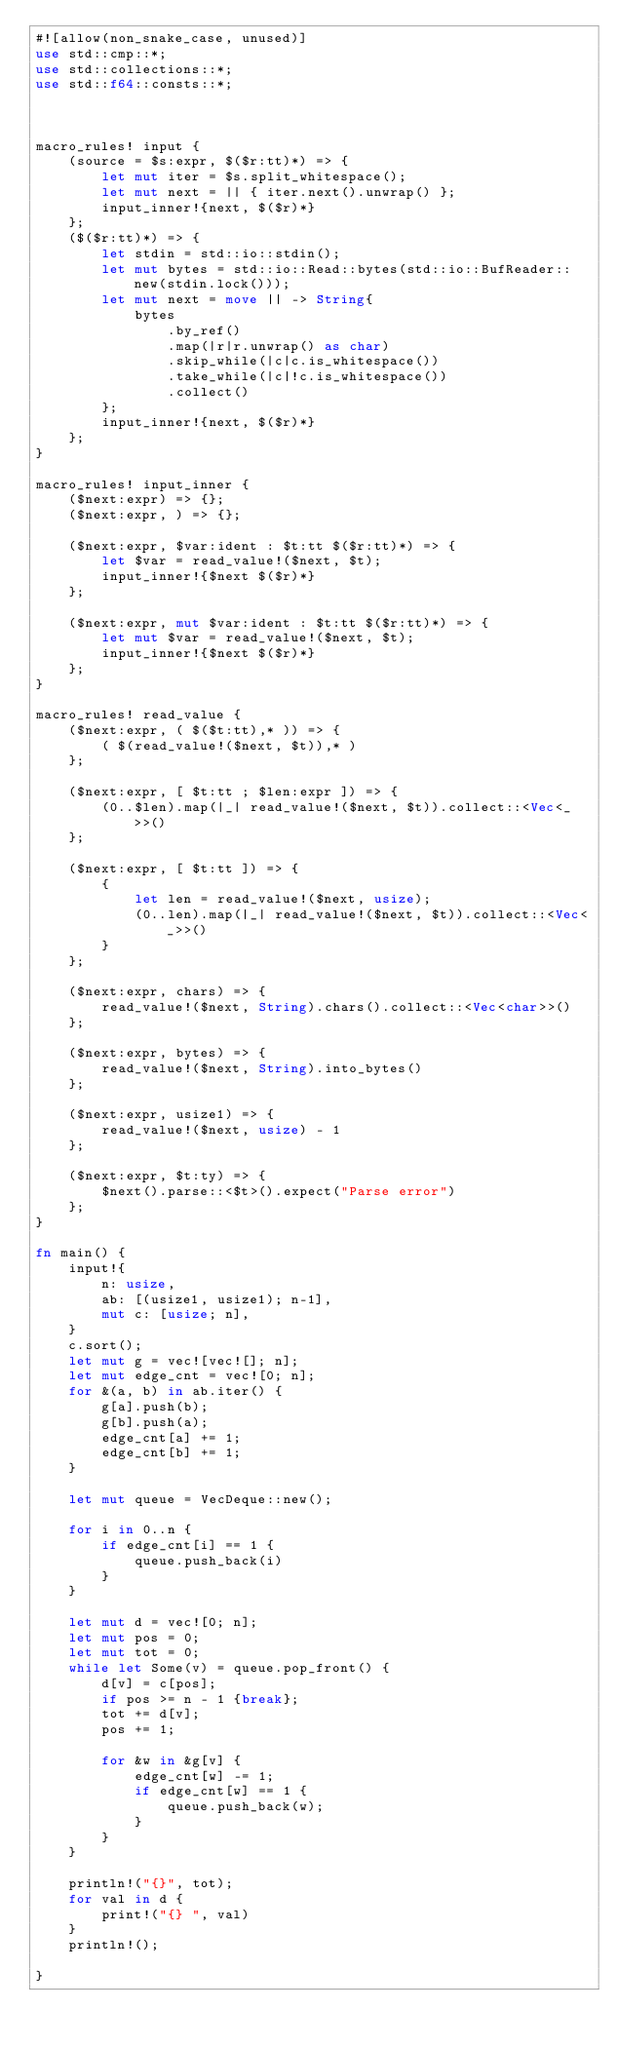<code> <loc_0><loc_0><loc_500><loc_500><_Rust_>#![allow(non_snake_case, unused)]
use std::cmp::*;
use std::collections::*;
use std::f64::consts::*;



macro_rules! input {
    (source = $s:expr, $($r:tt)*) => {
        let mut iter = $s.split_whitespace();
        let mut next = || { iter.next().unwrap() };
        input_inner!{next, $($r)*}
    };
    ($($r:tt)*) => {
        let stdin = std::io::stdin();
        let mut bytes = std::io::Read::bytes(std::io::BufReader::new(stdin.lock()));
        let mut next = move || -> String{
            bytes
                .by_ref()
                .map(|r|r.unwrap() as char)
                .skip_while(|c|c.is_whitespace())
                .take_while(|c|!c.is_whitespace())
                .collect()
        };
        input_inner!{next, $($r)*}
    };
}

macro_rules! input_inner {
    ($next:expr) => {};
    ($next:expr, ) => {};

    ($next:expr, $var:ident : $t:tt $($r:tt)*) => {
        let $var = read_value!($next, $t);
        input_inner!{$next $($r)*}
    };

    ($next:expr, mut $var:ident : $t:tt $($r:tt)*) => {
        let mut $var = read_value!($next, $t);
        input_inner!{$next $($r)*}
    };
}

macro_rules! read_value {
    ($next:expr, ( $($t:tt),* )) => {
        ( $(read_value!($next, $t)),* )
    };

    ($next:expr, [ $t:tt ; $len:expr ]) => {
        (0..$len).map(|_| read_value!($next, $t)).collect::<Vec<_>>()
    };

    ($next:expr, [ $t:tt ]) => {
        {
            let len = read_value!($next, usize);
            (0..len).map(|_| read_value!($next, $t)).collect::<Vec<_>>()
        }
    };

    ($next:expr, chars) => {
        read_value!($next, String).chars().collect::<Vec<char>>()
    };

    ($next:expr, bytes) => {
        read_value!($next, String).into_bytes()
    };

    ($next:expr, usize1) => {
        read_value!($next, usize) - 1
    };

    ($next:expr, $t:ty) => {
        $next().parse::<$t>().expect("Parse error")
    };
}

fn main() {
    input!{
        n: usize,
        ab: [(usize1, usize1); n-1],
        mut c: [usize; n],
    }
    c.sort();
    let mut g = vec![vec![]; n];
    let mut edge_cnt = vec![0; n];
    for &(a, b) in ab.iter() {
        g[a].push(b);
        g[b].push(a);
        edge_cnt[a] += 1;
        edge_cnt[b] += 1;
    }

    let mut queue = VecDeque::new();

    for i in 0..n {
        if edge_cnt[i] == 1 {
            queue.push_back(i)
        }
    }

    let mut d = vec![0; n];
    let mut pos = 0;
    let mut tot = 0;
    while let Some(v) = queue.pop_front() {
        d[v] = c[pos];
        if pos >= n - 1 {break};
        tot += d[v];
        pos += 1;

        for &w in &g[v] {
            edge_cnt[w] -= 1;
            if edge_cnt[w] == 1 {
                queue.push_back(w);
            }
        }
    }

    println!("{}", tot);
    for val in d {
        print!("{} ", val)
    }
    println!();

}
</code> 